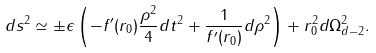<formula> <loc_0><loc_0><loc_500><loc_500>d s ^ { 2 } \simeq \pm \epsilon \left ( - f ^ { \prime } ( r _ { 0 } ) \frac { \rho ^ { 2 } } { 4 } d t ^ { 2 } + \frac { 1 } { f ^ { \prime } ( r _ { 0 } ) } d \rho ^ { 2 } \right ) + r ^ { 2 } _ { 0 } d \Omega ^ { 2 } _ { d - 2 } .</formula> 